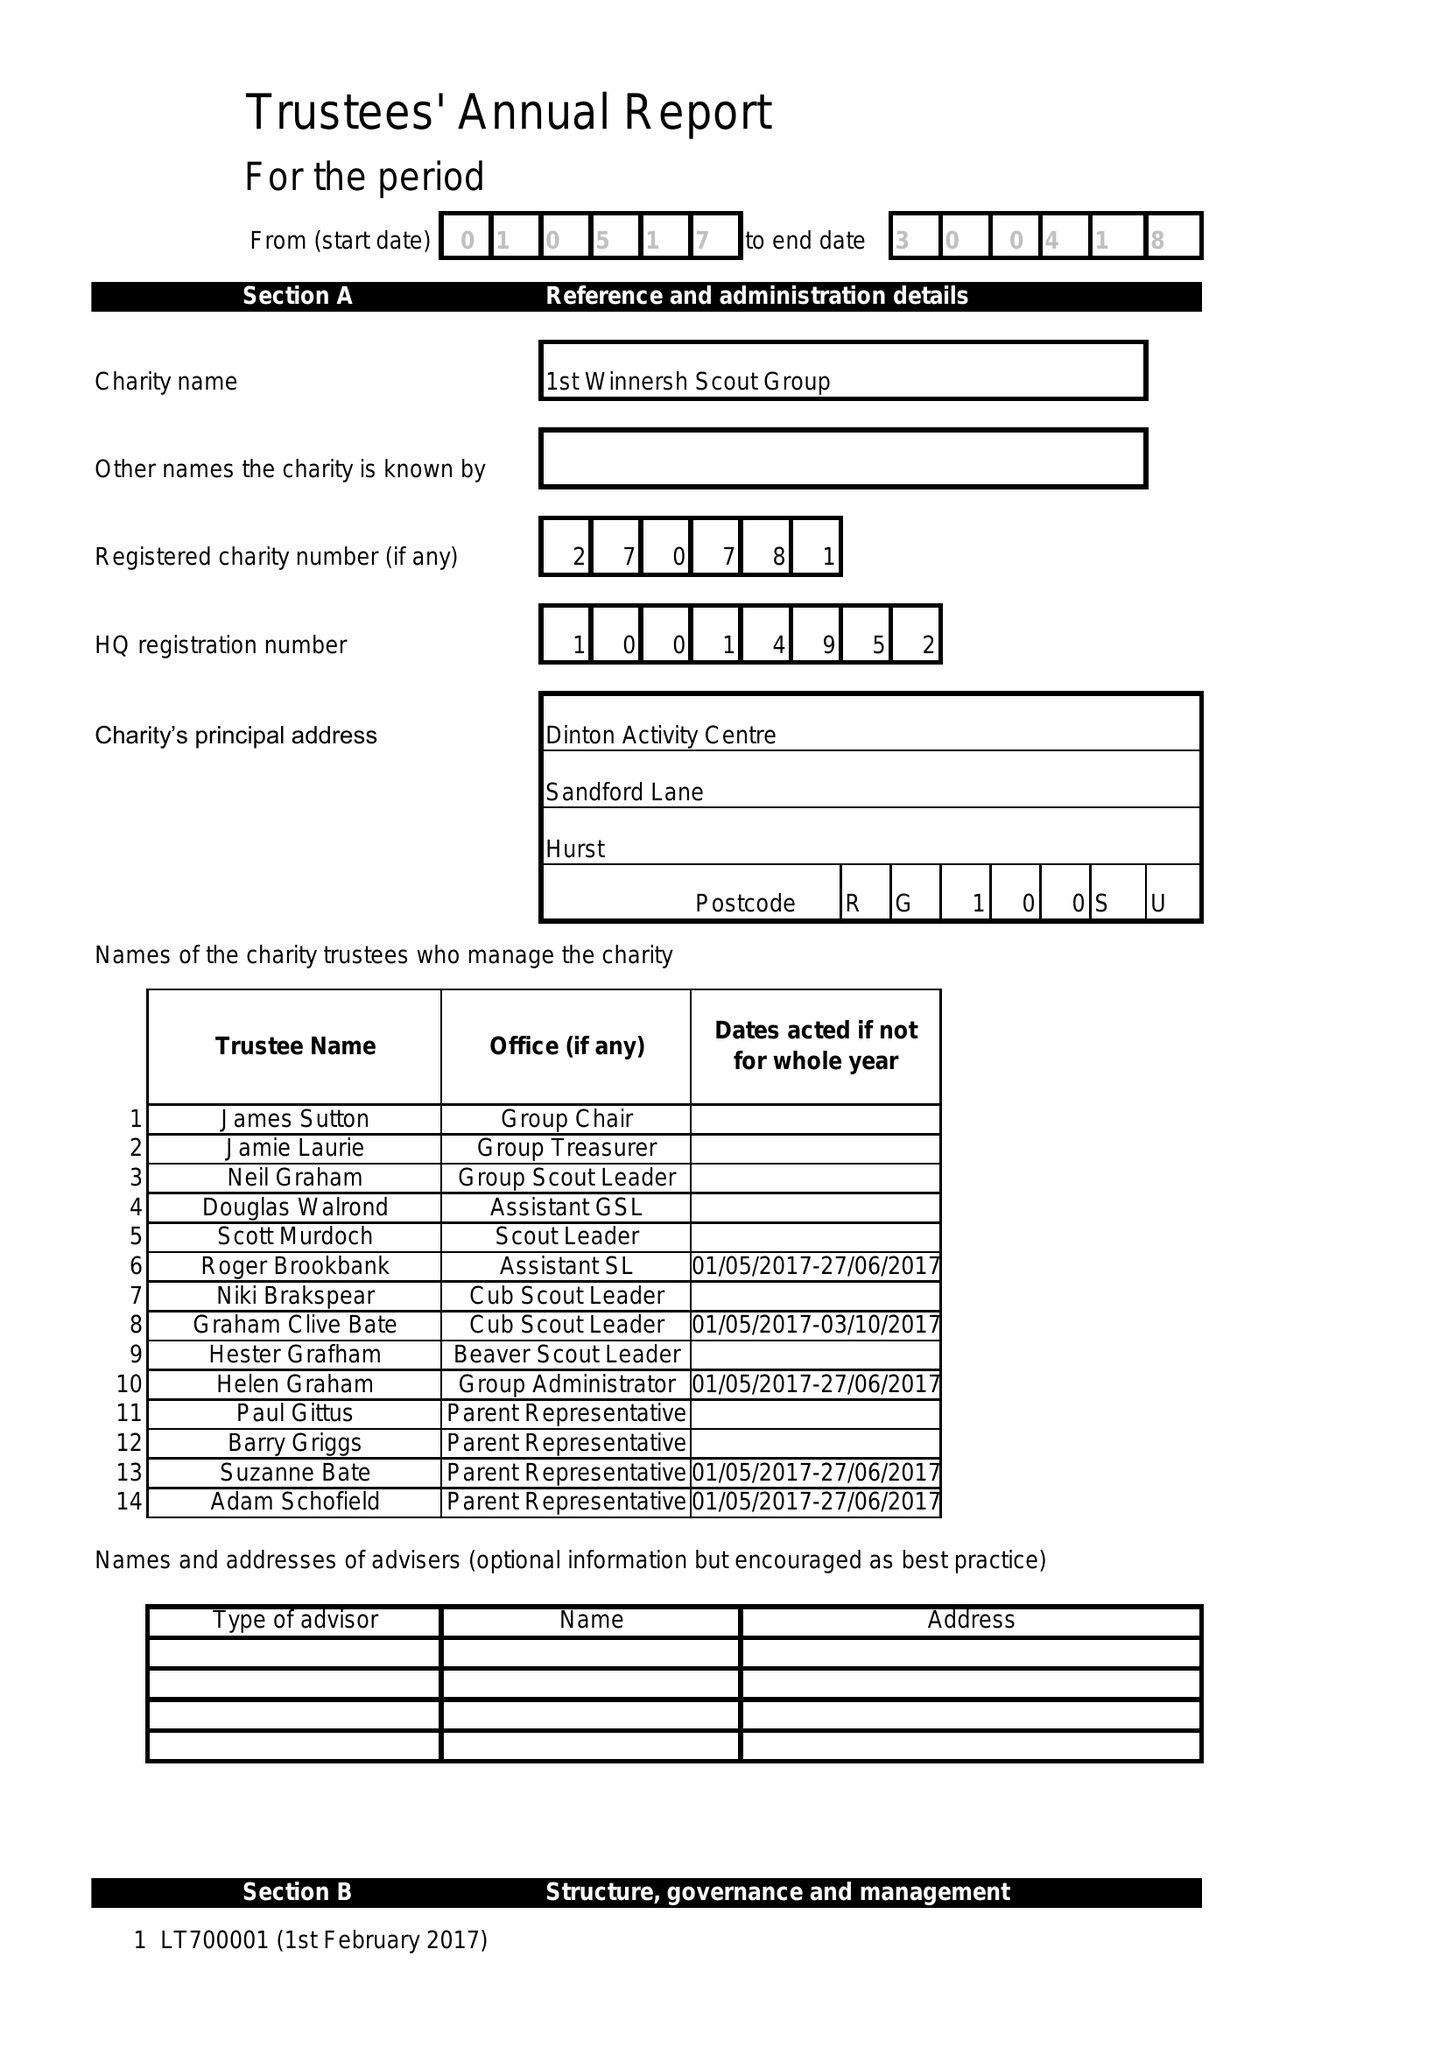What is the value for the income_annually_in_british_pounds?
Answer the question using a single word or phrase. 34680.00 